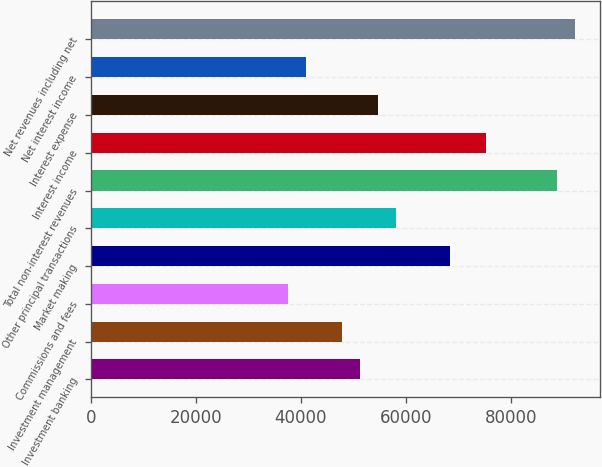Convert chart. <chart><loc_0><loc_0><loc_500><loc_500><bar_chart><fcel>Investment banking<fcel>Investment management<fcel>Commissions and fees<fcel>Market making<fcel>Other principal transactions<fcel>Total non-interest revenues<fcel>Interest income<fcel>Interest expense<fcel>Net interest income<fcel>Net revenues including net<nl><fcel>51301.2<fcel>47882.2<fcel>37625<fcel>68396.5<fcel>58139.3<fcel>88910.8<fcel>75234.6<fcel>54720.3<fcel>41044.1<fcel>92329.8<nl></chart> 